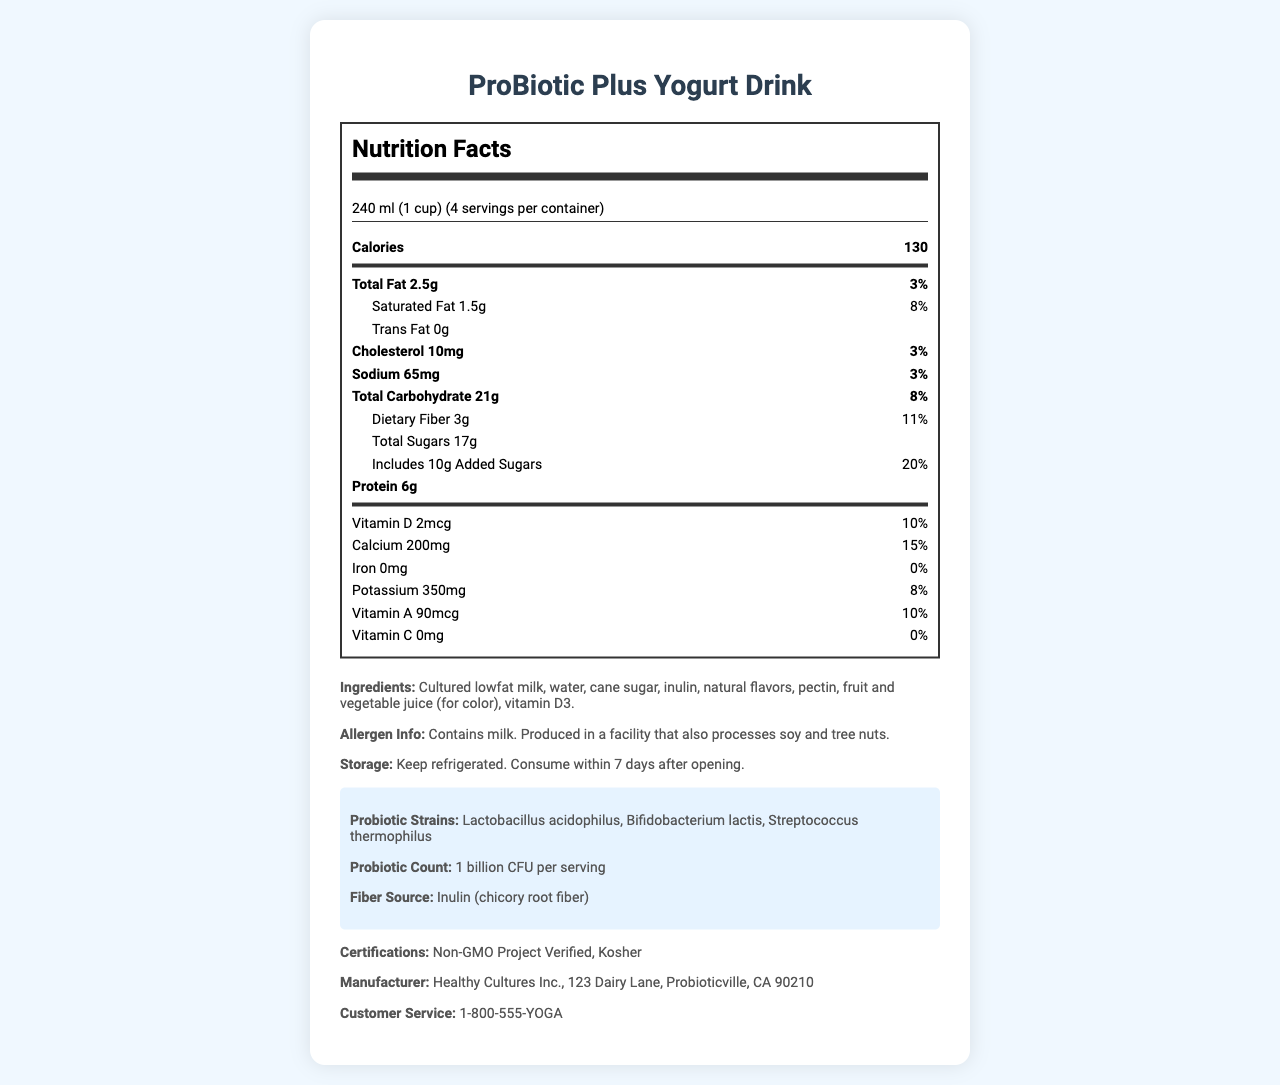what is the serving size? The serving size is directly stated as "240 ml (1 cup)" in the document.
Answer: 240 ml (1 cup) how many calories are there per serving? The document specifies "130" calories per serving.
Answer: 130 how much saturated fat is there per serving? The saturated fat per serving is listed as "1.5g".
Answer: 1.5g what is the daily value percentage for dietary fiber? The daily value percentage for dietary fiber is explicitly mentioned as "11%".
Answer: 11% how much protein does one serving contain? The amount of protein per serving is shown as "6g".
Answer: 6g which of the following certifications does the product have? A. USDA Organic B. Non-GMO Project Verified C. Halal D. Fair Trade The document lists "Non-GMO Project Verified" among the certifications.
Answer: B what source is the dietary fiber derived from? A. Oats B. Psyllium Husk C. Inulin (chicory root fiber) D. Cellulose The dietary fiber source is specified as "Inulin (chicory root fiber)".
Answer: C does the product contain any vitamin C? The document states "Vitamin C: 0mg" indicating that there is no vitamin C in the product.
Answer: No describe the main nutritional components of one serving of the ProBiotic Plus Yogurt Drink. The document outlines the specific amounts and daily values for calories, fats, cholesterol, sodium, carbohydrates, sugars, proteins, and various vitamins and minerals in a serving.
Answer: The main nutritional components include 130 calories, 2.5g of total fat (with 1.5g saturated fat), 10mg cholesterol, 65mg sodium, 21g total carbohydrates (with 3g dietary fiber and 17g total sugars, of which 10g are added sugars), and 6g protein. Additionally, it contains several vitamins and minerals, including vitamin D, calcium, and potassium. what is the number of probiotic CFUs per serving? The document states "Probiotic Count: 1 billion CFU per serving".
Answer: 1 billion CFU can the total iron content be found in the document? The document lists the iron content as "0mg".
Answer: Yes who is the manufacturer of the product? The manufacturer information is explicitly stated.
Answer: Healthy Cultures Inc., 123 Dairy Lane, Probioticville, CA 90210 what is the maximum number of days for consuming the product after it's opened? The storage instructions advise consuming the product within 7 days after opening.
Answer: 7 days what is the percentage of daily value of added sugars? The document shows "Added Sugars: 10g (20% Daily Value)".
Answer: 20% name one of the probiotic strains included in the yogurt drink. One of the listed probiotic strains is Lactobacillus acidophilus. The other strains listed are Bifidobacterium lactis and Streptococcus thermophilus.
Answer: Lactobacillus acidophilus what is the customer service phone number? The customer service phone number is provided in the document.
Answer: 1-800-555-YOGA what are the colors of the juice ingredients used? The document mentions "fruit and vegetable juice (for color)", but it does not specify which colors the juices are.
Answer: Not enough information 